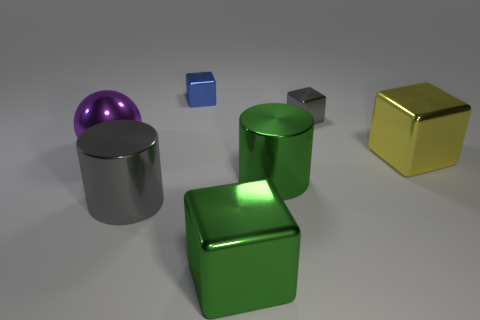Subtract all blue blocks. How many blocks are left? 3 Subtract all green cubes. How many cubes are left? 3 Add 3 yellow metal cubes. How many objects exist? 10 Subtract all red cubes. Subtract all green balls. How many cubes are left? 4 Subtract 0 yellow balls. How many objects are left? 7 Subtract all spheres. How many objects are left? 6 Subtract all big brown shiny things. Subtract all yellow things. How many objects are left? 6 Add 5 tiny blue metal objects. How many tiny blue metal objects are left? 6 Add 4 tiny blue rubber balls. How many tiny blue rubber balls exist? 4 